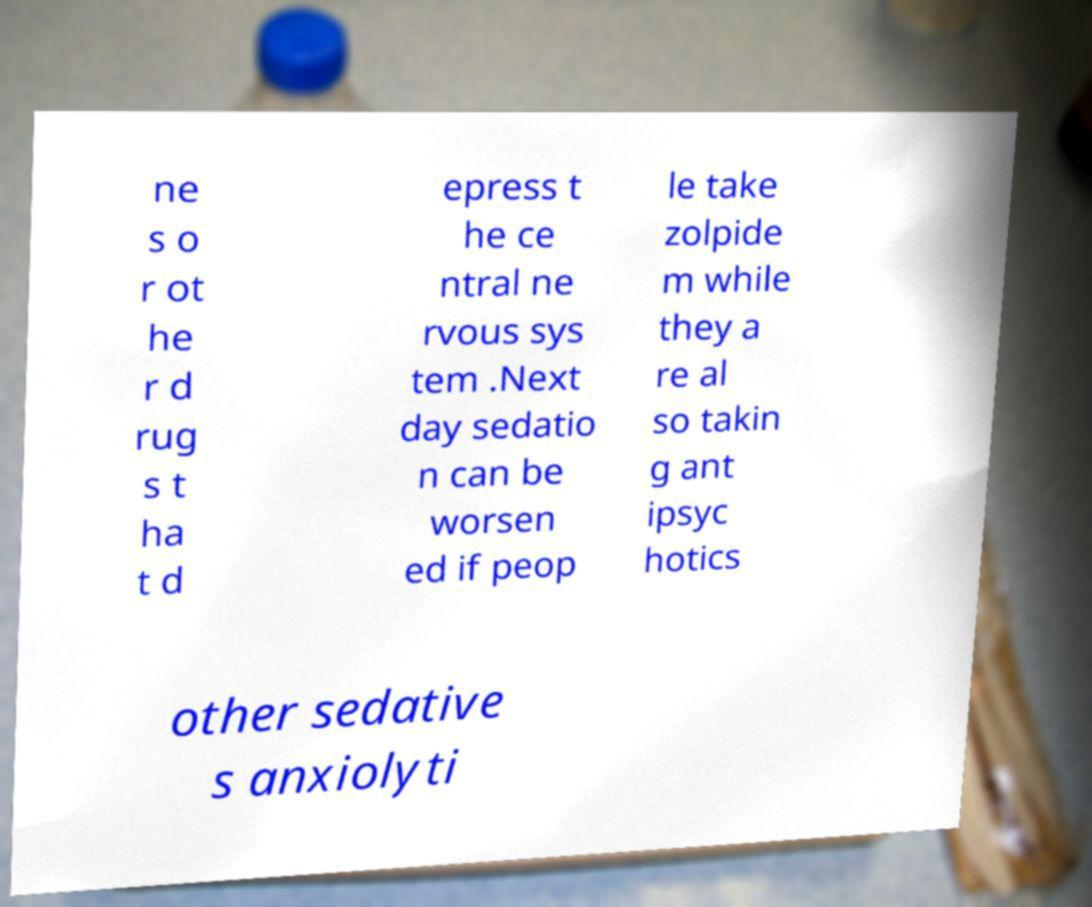Please identify and transcribe the text found in this image. ne s o r ot he r d rug s t ha t d epress t he ce ntral ne rvous sys tem .Next day sedatio n can be worsen ed if peop le take zolpide m while they a re al so takin g ant ipsyc hotics other sedative s anxiolyti 